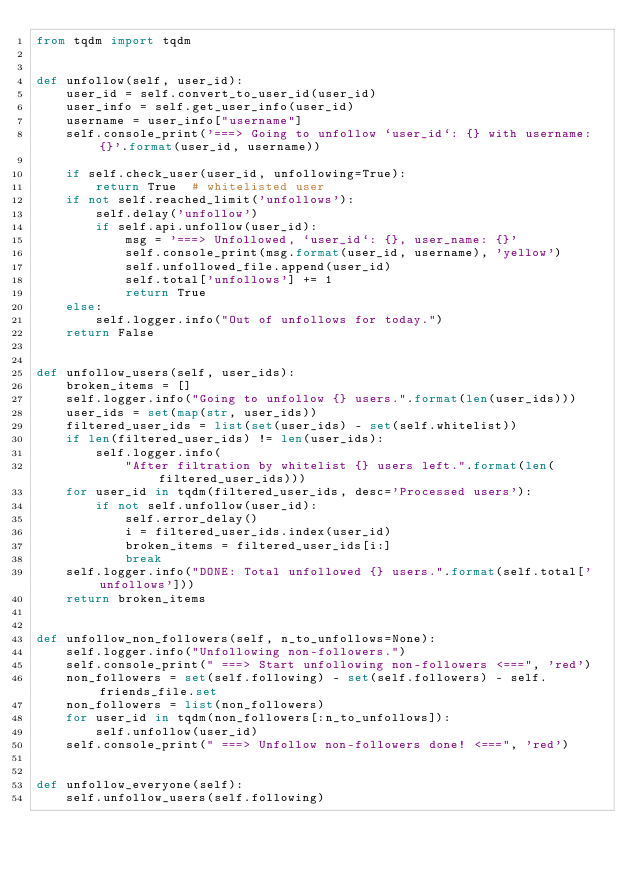<code> <loc_0><loc_0><loc_500><loc_500><_Python_>from tqdm import tqdm


def unfollow(self, user_id):
    user_id = self.convert_to_user_id(user_id)
    user_info = self.get_user_info(user_id)
    username = user_info["username"]
    self.console_print('===> Going to unfollow `user_id`: {} with username: {}'.format(user_id, username))

    if self.check_user(user_id, unfollowing=True):
        return True  # whitelisted user
    if not self.reached_limit('unfollows'):
        self.delay('unfollow')
        if self.api.unfollow(user_id):
            msg = '===> Unfollowed, `user_id`: {}, user_name: {}'
            self.console_print(msg.format(user_id, username), 'yellow')
            self.unfollowed_file.append(user_id)
            self.total['unfollows'] += 1
            return True
    else:
        self.logger.info("Out of unfollows for today.")
    return False


def unfollow_users(self, user_ids):
    broken_items = []
    self.logger.info("Going to unfollow {} users.".format(len(user_ids)))
    user_ids = set(map(str, user_ids))
    filtered_user_ids = list(set(user_ids) - set(self.whitelist))
    if len(filtered_user_ids) != len(user_ids):
        self.logger.info(
            "After filtration by whitelist {} users left.".format(len(filtered_user_ids)))
    for user_id in tqdm(filtered_user_ids, desc='Processed users'):
        if not self.unfollow(user_id):
            self.error_delay()
            i = filtered_user_ids.index(user_id)
            broken_items = filtered_user_ids[i:]
            break
    self.logger.info("DONE: Total unfollowed {} users.".format(self.total['unfollows']))
    return broken_items


def unfollow_non_followers(self, n_to_unfollows=None):
    self.logger.info("Unfollowing non-followers.")
    self.console_print(" ===> Start unfollowing non-followers <===", 'red')
    non_followers = set(self.following) - set(self.followers) - self.friends_file.set
    non_followers = list(non_followers)
    for user_id in tqdm(non_followers[:n_to_unfollows]):
        self.unfollow(user_id)
    self.console_print(" ===> Unfollow non-followers done! <===", 'red')


def unfollow_everyone(self):
    self.unfollow_users(self.following)
</code> 